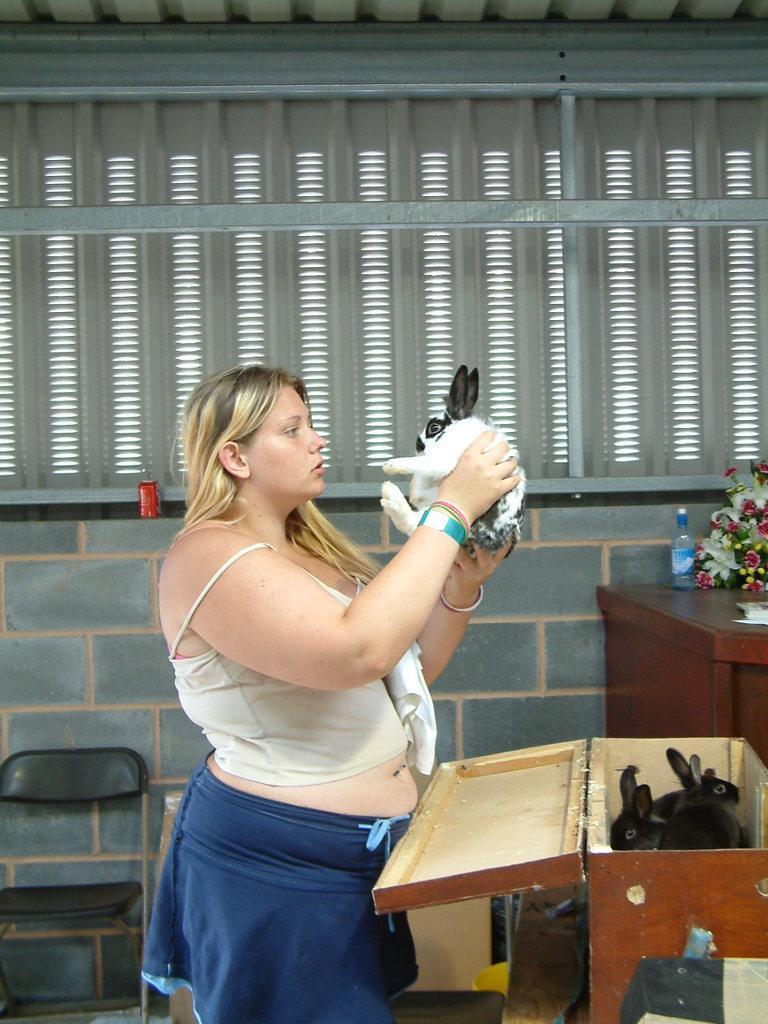Please provide a concise description of this image. In this picture we can see a woman standing and holding a rabbit in her hand. We can see rabbits in this box. On the table we can see flower bouquet and a bottle. Here we can see tin. This is a chair. This is a wall. 